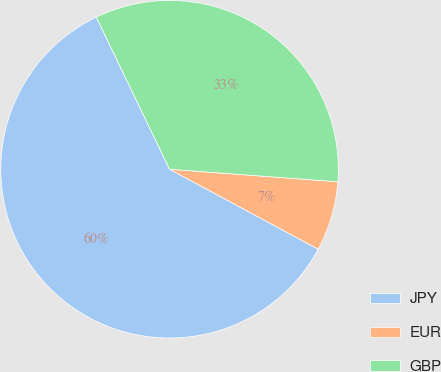Convert chart. <chart><loc_0><loc_0><loc_500><loc_500><pie_chart><fcel>JPY<fcel>EUR<fcel>GBP<nl><fcel>60.0%<fcel>6.67%<fcel>33.33%<nl></chart> 